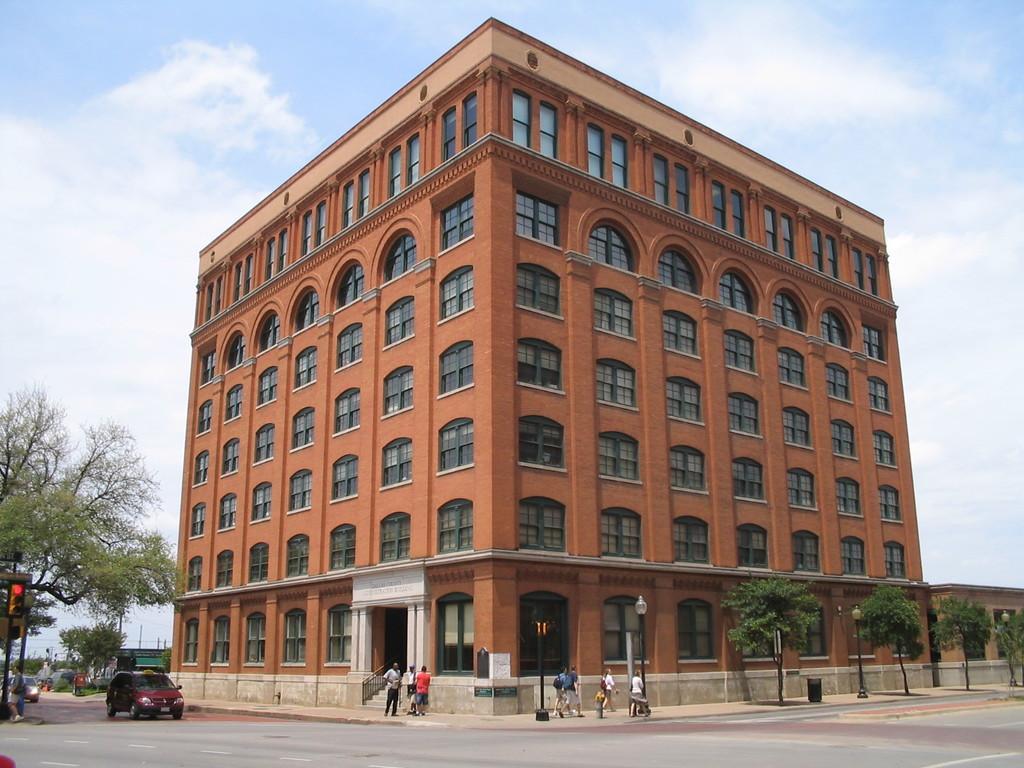Can you describe this image briefly? In this image, I can see a building with windows. There are few people standing and few people walking on the pathway. At the bottom of the image, there are trees, light poles and vehicles on the road. At the bottom left side of the image, I can see a traffic light. In the background, there is the sky. 